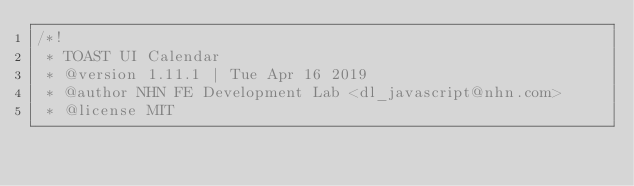Convert code to text. <code><loc_0><loc_0><loc_500><loc_500><_CSS_>/*!
 * TOAST UI Calendar
 * @version 1.11.1 | Tue Apr 16 2019
 * @author NHN FE Development Lab <dl_javascript@nhn.com>
 * @license MIT</code> 